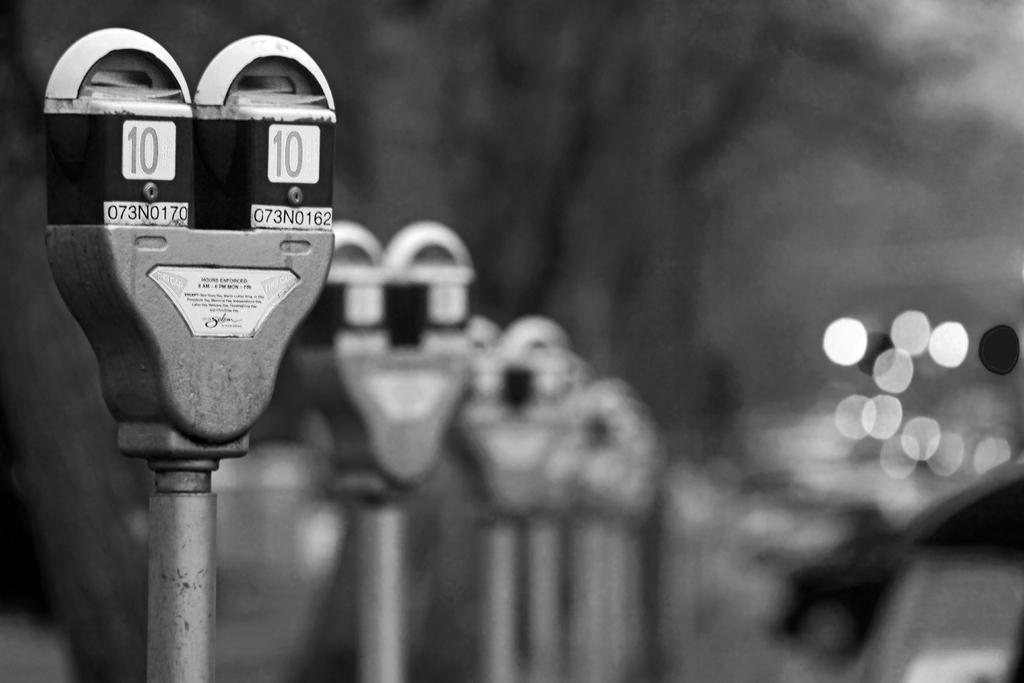Provide a one-sentence caption for the provided image. A black and white picture of parking meters with meter number 10 at the forefront. 